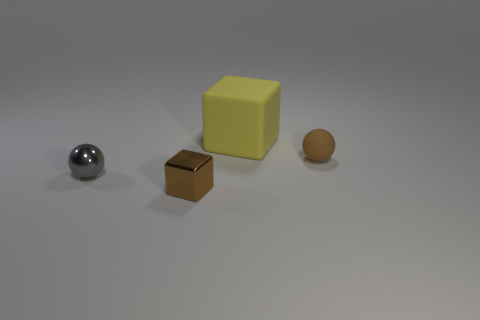There is a gray metal object left of the large cube; is it the same shape as the tiny object behind the tiny shiny ball?
Provide a short and direct response. Yes. What is the shape of the tiny thing that is on the right side of the gray shiny thing and on the left side of the big cube?
Offer a very short reply. Cube. The cube that is the same material as the small brown sphere is what size?
Offer a very short reply. Large. Is the number of small brown shiny things less than the number of brown things?
Offer a terse response. Yes. There is a small brown object that is in front of the tiny metallic thing that is behind the brown thing to the left of the yellow rubber object; what is it made of?
Make the answer very short. Metal. Do the object right of the big matte block and the cube that is behind the shiny ball have the same material?
Offer a very short reply. Yes. What size is the thing that is behind the gray sphere and left of the brown rubber ball?
Your response must be concise. Large. What material is the brown block that is the same size as the gray object?
Give a very brief answer. Metal. How many small brown things are to the left of the tiny ball that is on the right side of the tiny shiny ball on the left side of the tiny cube?
Your response must be concise. 1. There is a small thing that is in front of the gray object; is its color the same as the ball behind the gray metallic thing?
Provide a short and direct response. Yes. 